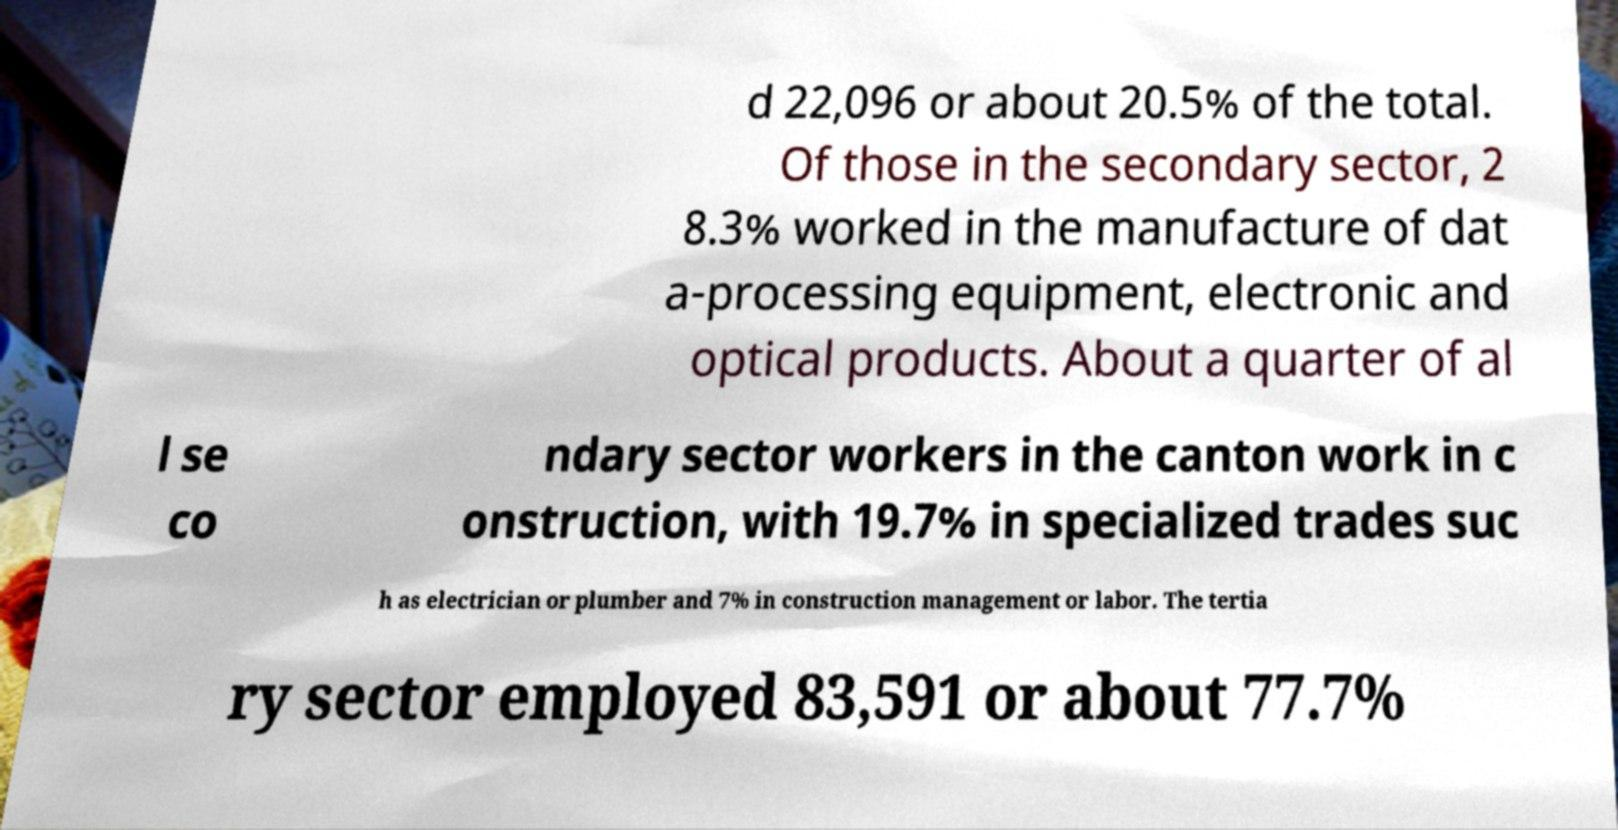Can you read and provide the text displayed in the image?This photo seems to have some interesting text. Can you extract and type it out for me? d 22,096 or about 20.5% of the total. Of those in the secondary sector, 2 8.3% worked in the manufacture of dat a-processing equipment, electronic and optical products. About a quarter of al l se co ndary sector workers in the canton work in c onstruction, with 19.7% in specialized trades suc h as electrician or plumber and 7% in construction management or labor. The tertia ry sector employed 83,591 or about 77.7% 